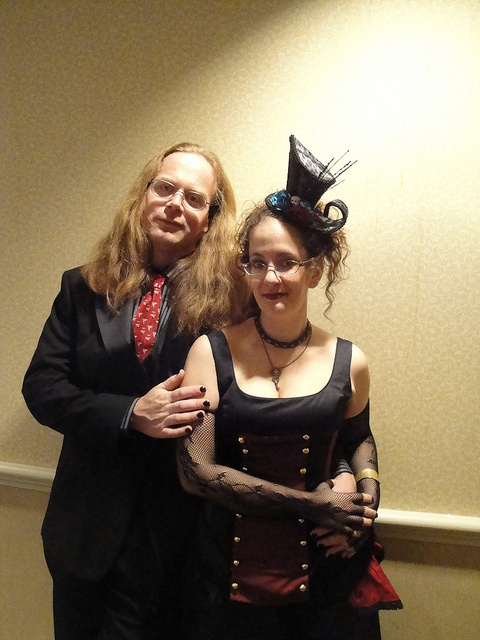Describe the objects in this image and their specific colors. I can see people in olive, black, maroon, gray, and beige tones, people in olive, black, maroon, gray, and tan tones, and tie in olive, brown, and maroon tones in this image. 